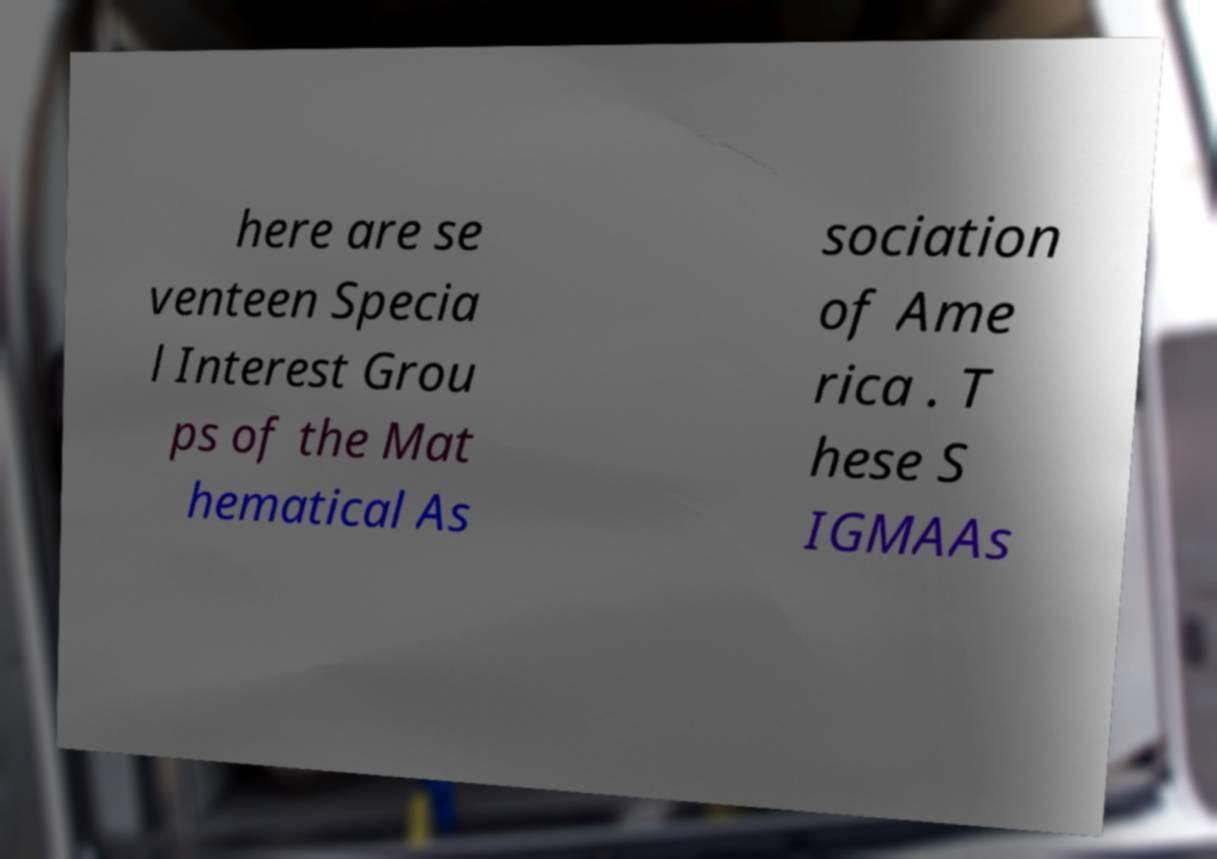Can you read and provide the text displayed in the image?This photo seems to have some interesting text. Can you extract and type it out for me? here are se venteen Specia l Interest Grou ps of the Mat hematical As sociation of Ame rica . T hese S IGMAAs 